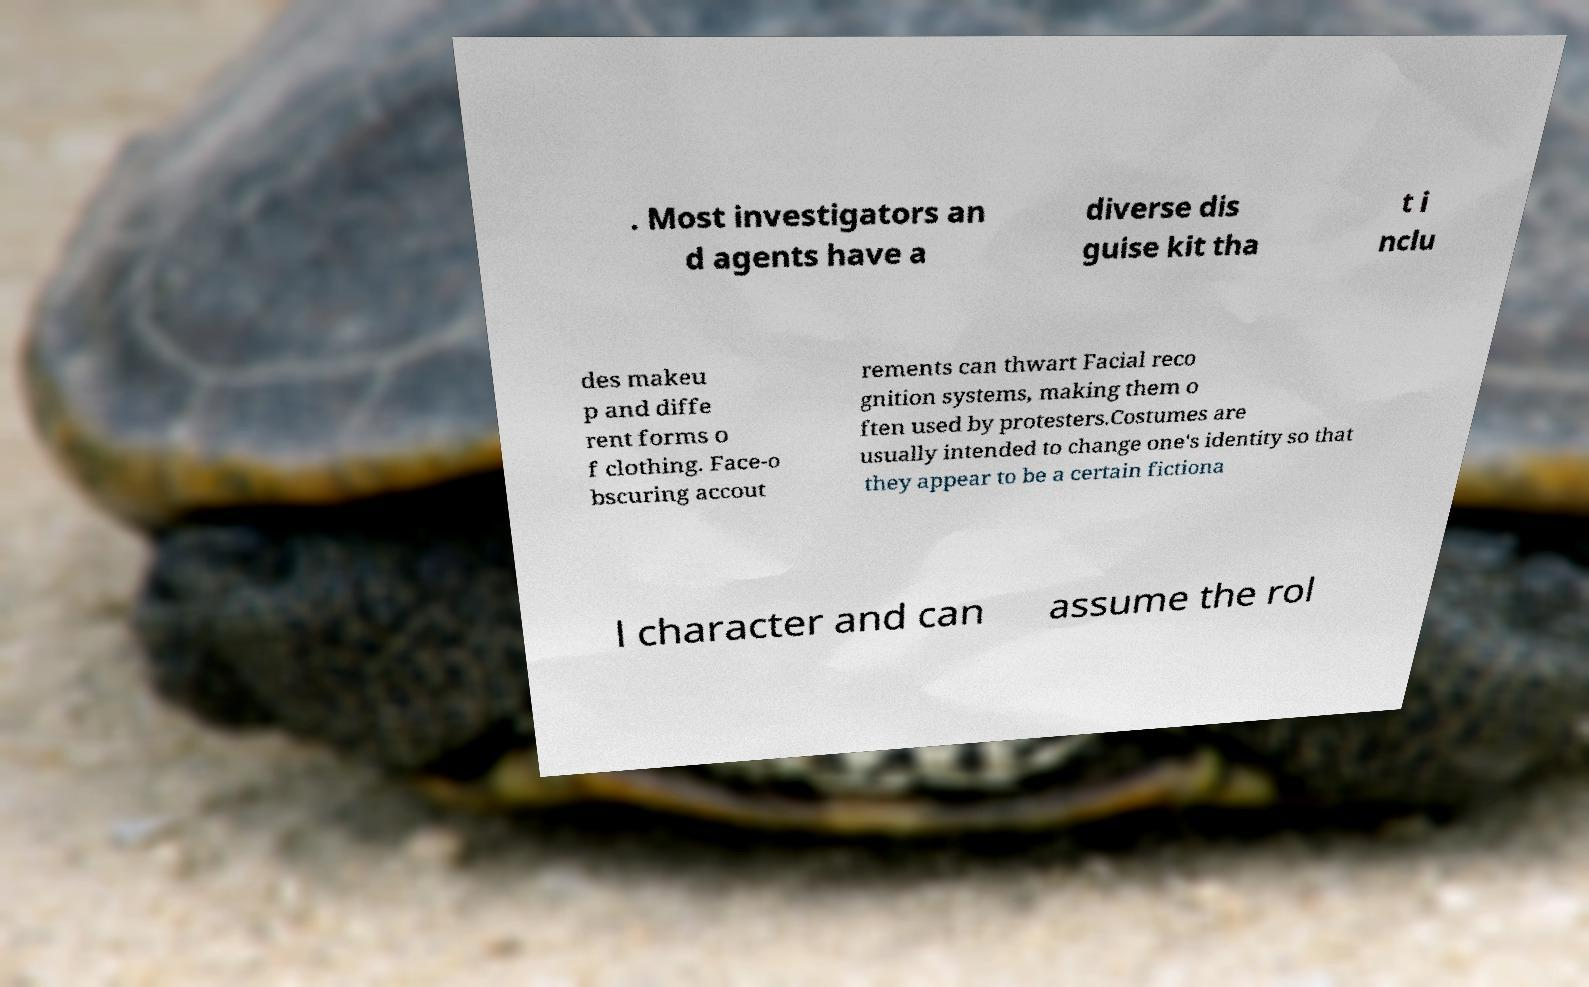Can you read and provide the text displayed in the image?This photo seems to have some interesting text. Can you extract and type it out for me? . Most investigators an d agents have a diverse dis guise kit tha t i nclu des makeu p and diffe rent forms o f clothing. Face-o bscuring accout rements can thwart Facial reco gnition systems, making them o ften used by protesters.Costumes are usually intended to change one's identity so that they appear to be a certain fictiona l character and can assume the rol 